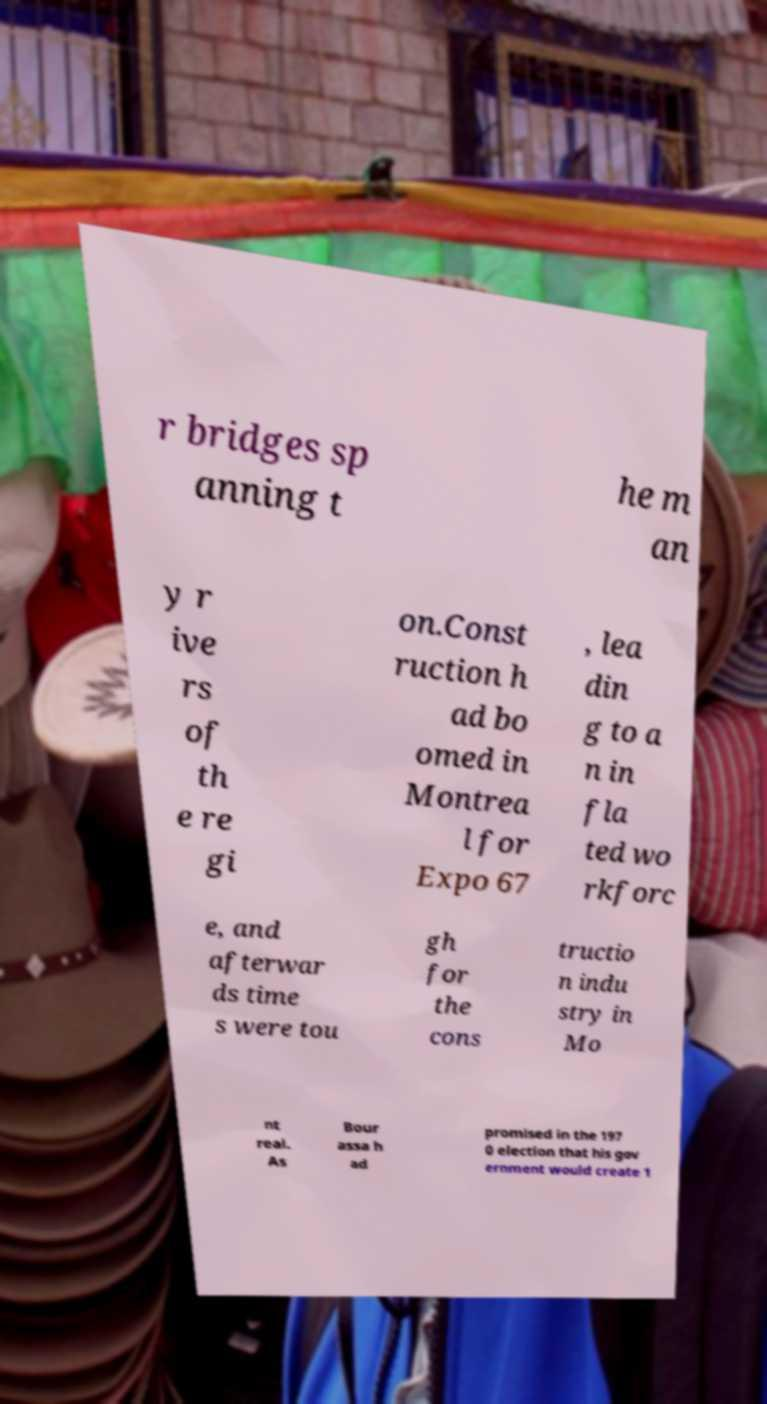Please read and relay the text visible in this image. What does it say? r bridges sp anning t he m an y r ive rs of th e re gi on.Const ruction h ad bo omed in Montrea l for Expo 67 , lea din g to a n in fla ted wo rkforc e, and afterwar ds time s were tou gh for the cons tructio n indu stry in Mo nt real. As Bour assa h ad promised in the 197 0 election that his gov ernment would create 1 